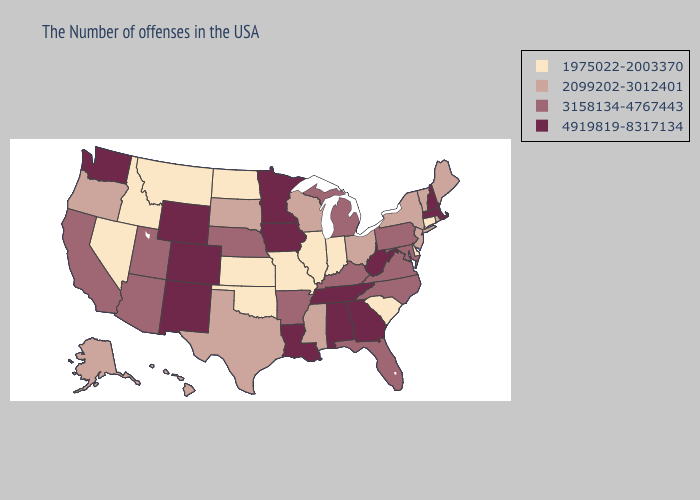Does the map have missing data?
Keep it brief. No. What is the highest value in the Northeast ?
Give a very brief answer. 4919819-8317134. Which states hav the highest value in the South?
Quick response, please. West Virginia, Georgia, Alabama, Tennessee, Louisiana. Among the states that border Kentucky , does Missouri have the lowest value?
Write a very short answer. Yes. Does New Hampshire have the highest value in the USA?
Keep it brief. Yes. Does Florida have a lower value than New Hampshire?
Concise answer only. Yes. How many symbols are there in the legend?
Be succinct. 4. Does Connecticut have the lowest value in the Northeast?
Give a very brief answer. Yes. What is the highest value in the West ?
Quick response, please. 4919819-8317134. Name the states that have a value in the range 4919819-8317134?
Write a very short answer. Massachusetts, New Hampshire, West Virginia, Georgia, Alabama, Tennessee, Louisiana, Minnesota, Iowa, Wyoming, Colorado, New Mexico, Washington. Does Iowa have the highest value in the MidWest?
Give a very brief answer. Yes. Is the legend a continuous bar?
Give a very brief answer. No. Does Mississippi have the highest value in the USA?
Write a very short answer. No. Name the states that have a value in the range 1975022-2003370?
Short answer required. Connecticut, Delaware, South Carolina, Indiana, Illinois, Missouri, Kansas, Oklahoma, North Dakota, Montana, Idaho, Nevada. 